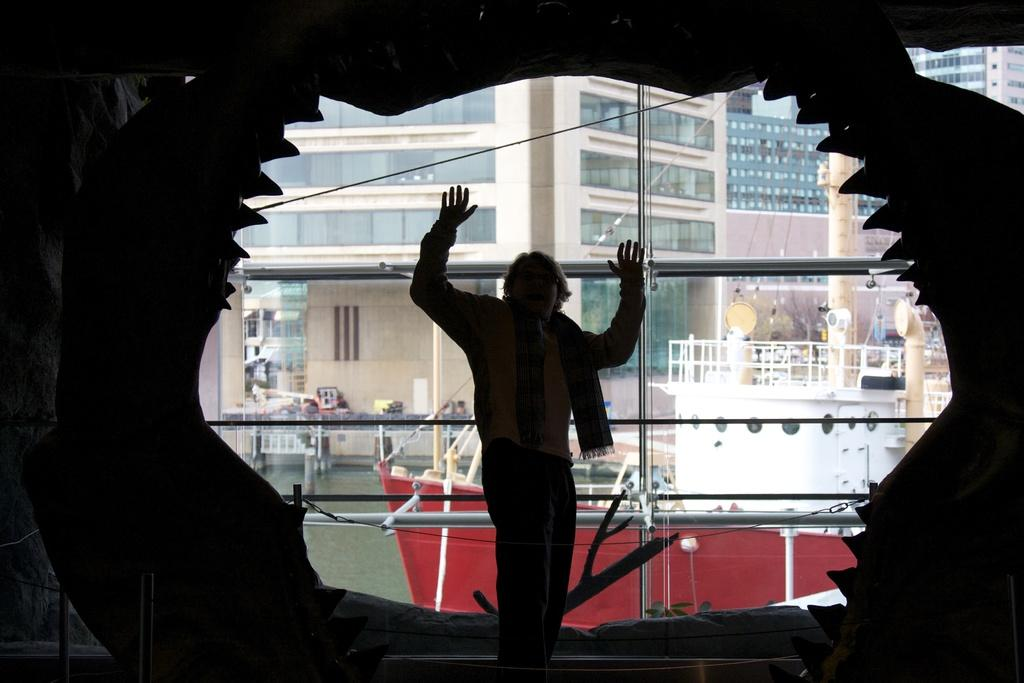Who is present in the image? There is a man in the image. What can be seen in the background of the image? There is a ship on the water and buildings visible in the background of the image. What type of beef is being served on the ship in the image? There is no beef present in the image, as it only features a man and a ship on the water in the background. 